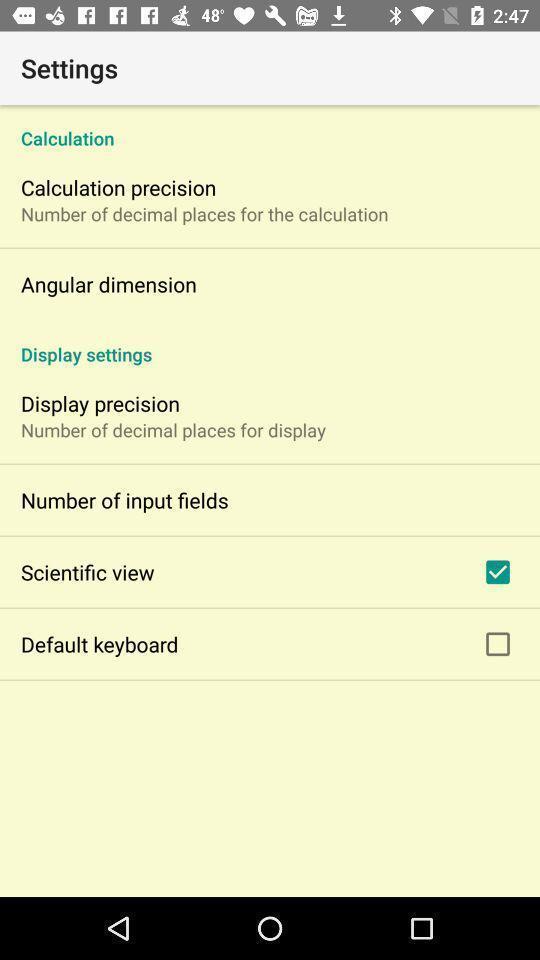Explain the elements present in this screenshot. Screen shows settings. 